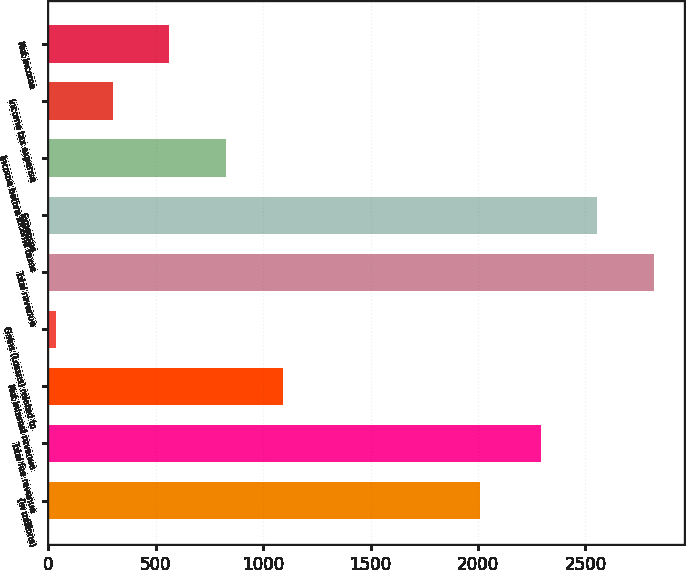Convert chart to OTSL. <chart><loc_0><loc_0><loc_500><loc_500><bar_chart><fcel>(In millions)<fcel>Total fee revenue<fcel>Net interest revenue<fcel>Gains (Losses) related to<fcel>Total revenue<fcel>Expenses<fcel>Income before income taxes<fcel>Income tax expense<fcel>Net income<nl><fcel>2009<fcel>2291<fcel>1092.6<fcel>37<fcel>2818.8<fcel>2554.9<fcel>828.7<fcel>300.9<fcel>564.8<nl></chart> 